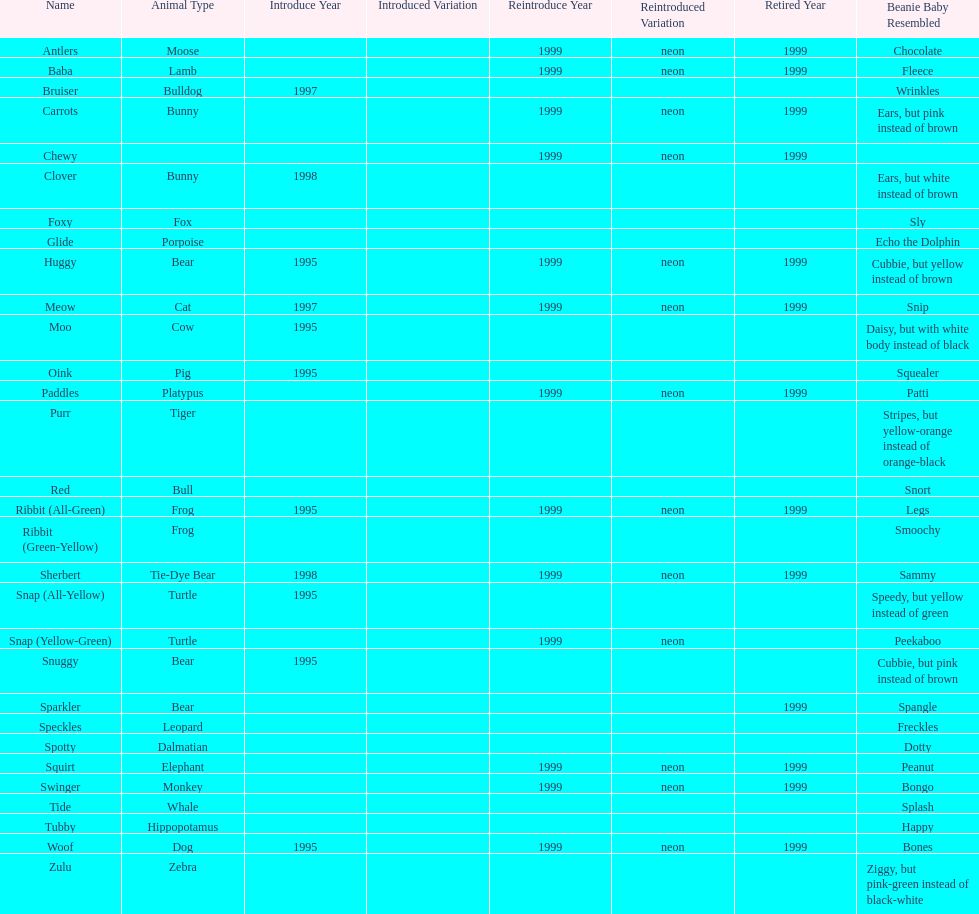What is the number of frog pillow pals? 2. 